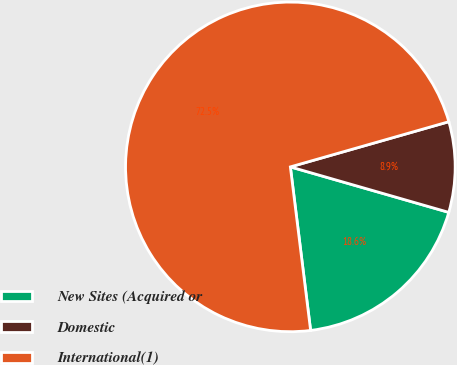<chart> <loc_0><loc_0><loc_500><loc_500><pie_chart><fcel>New Sites (Acquired or<fcel>Domestic<fcel>International(1)<nl><fcel>18.59%<fcel>8.87%<fcel>72.54%<nl></chart> 